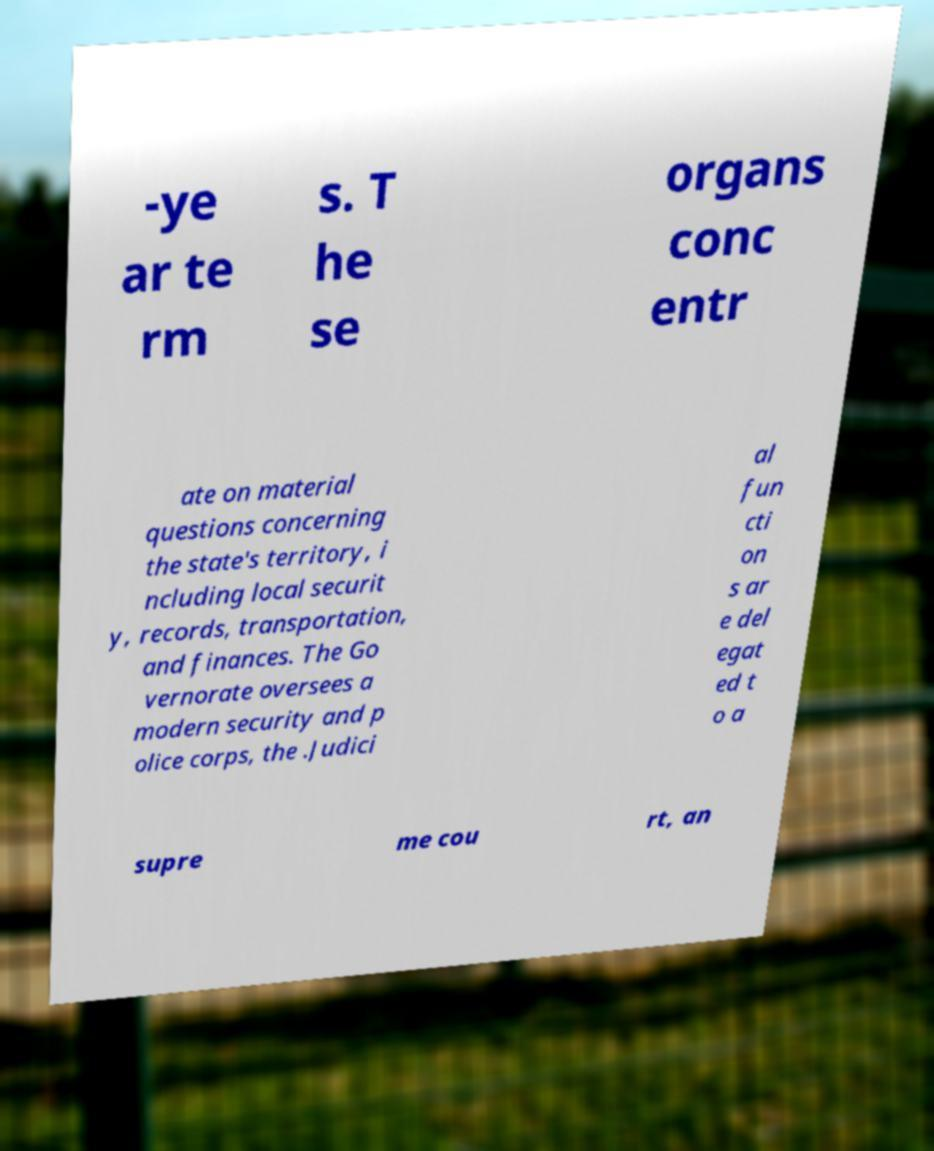Can you accurately transcribe the text from the provided image for me? -ye ar te rm s. T he se organs conc entr ate on material questions concerning the state's territory, i ncluding local securit y, records, transportation, and finances. The Go vernorate oversees a modern security and p olice corps, the .Judici al fun cti on s ar e del egat ed t o a supre me cou rt, an 